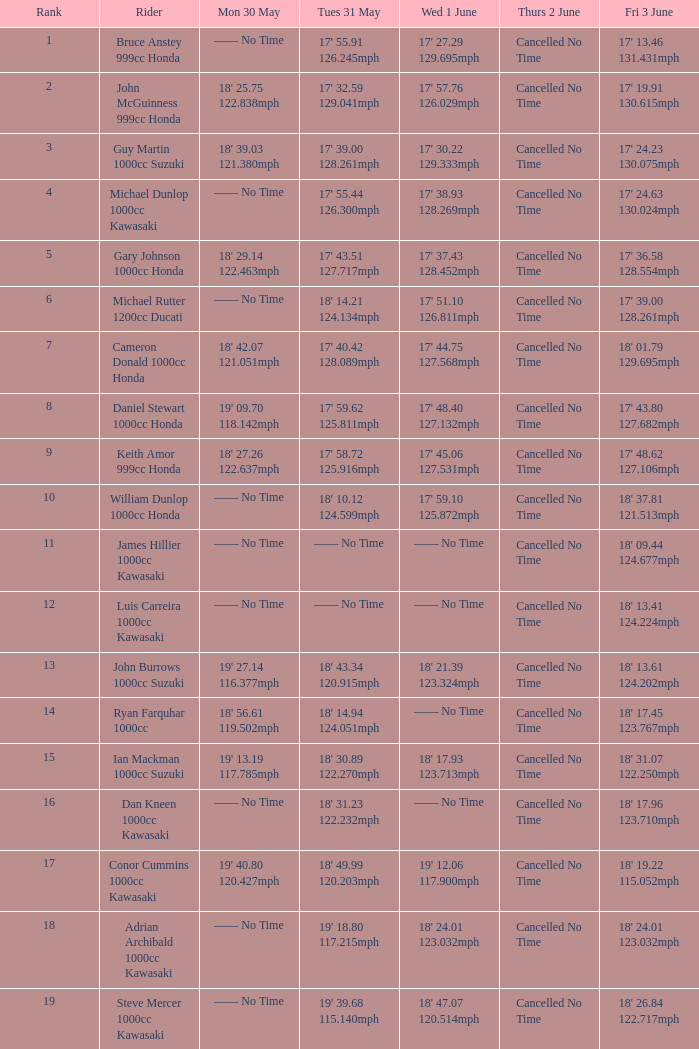If a rider's time on june 3rd was 17' 13.46 with a speed of 131.431mph, what was their time on may 30th? —— No Time. 